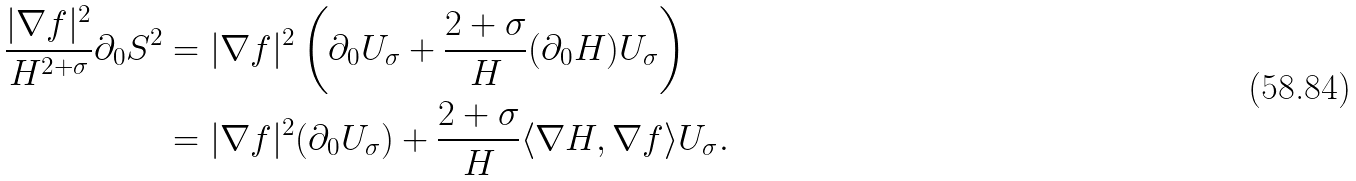<formula> <loc_0><loc_0><loc_500><loc_500>\frac { | \nabla f | ^ { 2 } } { H ^ { 2 + \sigma } } \partial _ { 0 } S ^ { 2 } & = | \nabla f | ^ { 2 } \left ( \partial _ { 0 } U _ { \sigma } + \frac { 2 + \sigma } { H } ( \partial _ { 0 } H ) U _ { \sigma } \right ) \\ & = | \nabla f | ^ { 2 } ( \partial _ { 0 } U _ { \sigma } ) + \frac { 2 + \sigma } { H } \langle \nabla H , \nabla f \rangle U _ { \sigma } .</formula> 